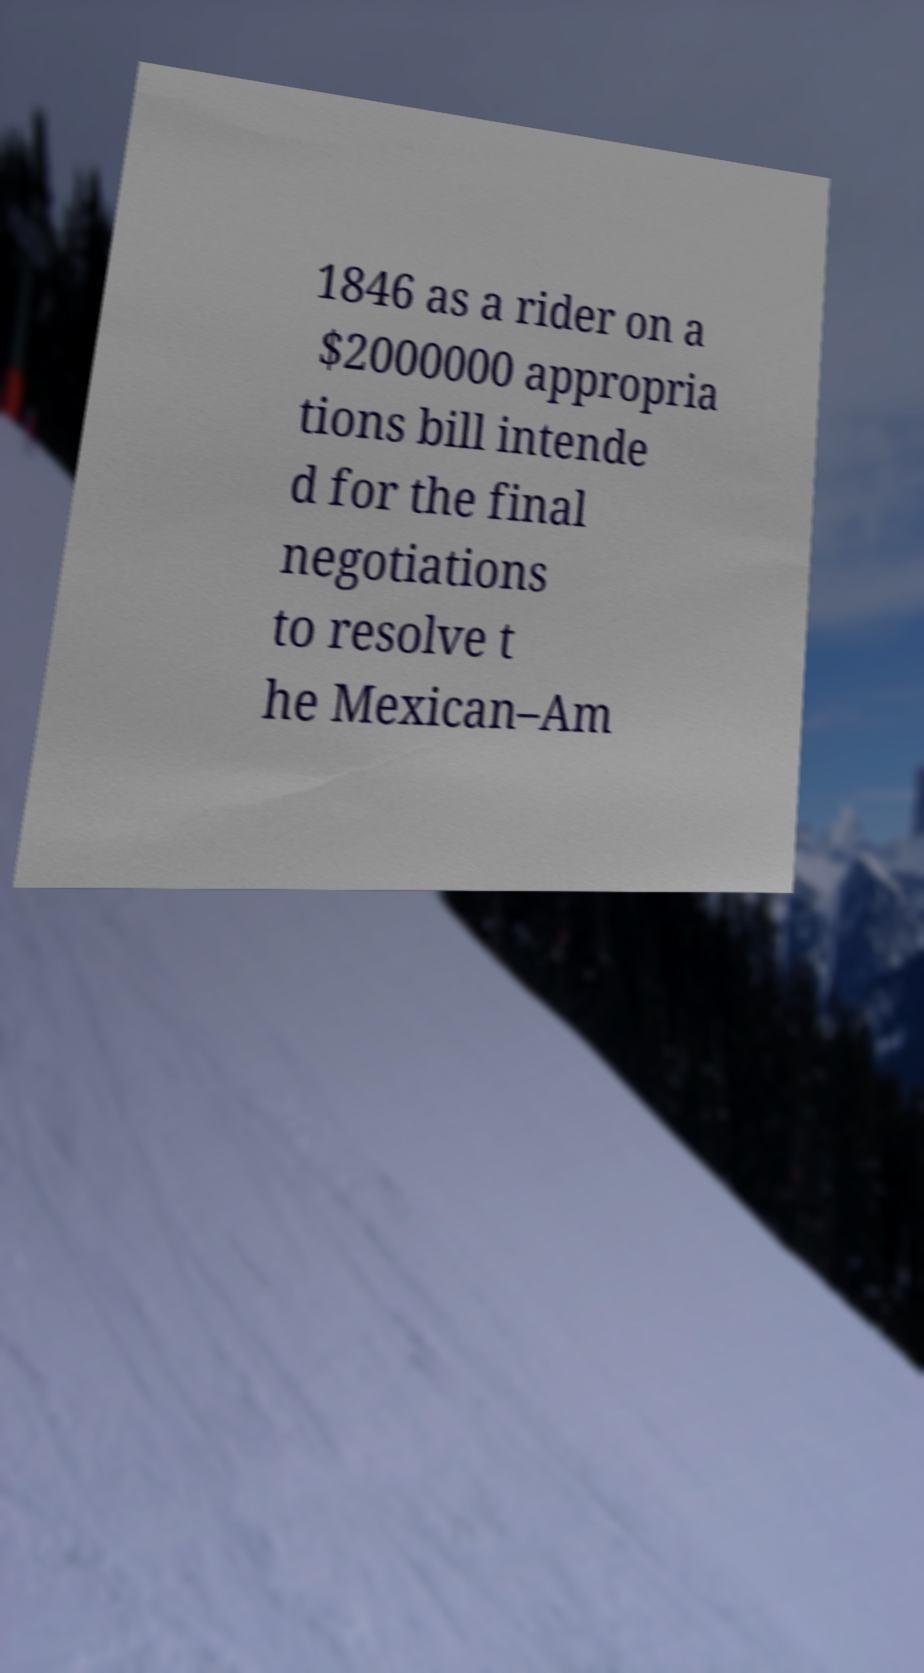Please identify and transcribe the text found in this image. 1846 as a rider on a $2000000 appropria tions bill intende d for the final negotiations to resolve t he Mexican–Am 